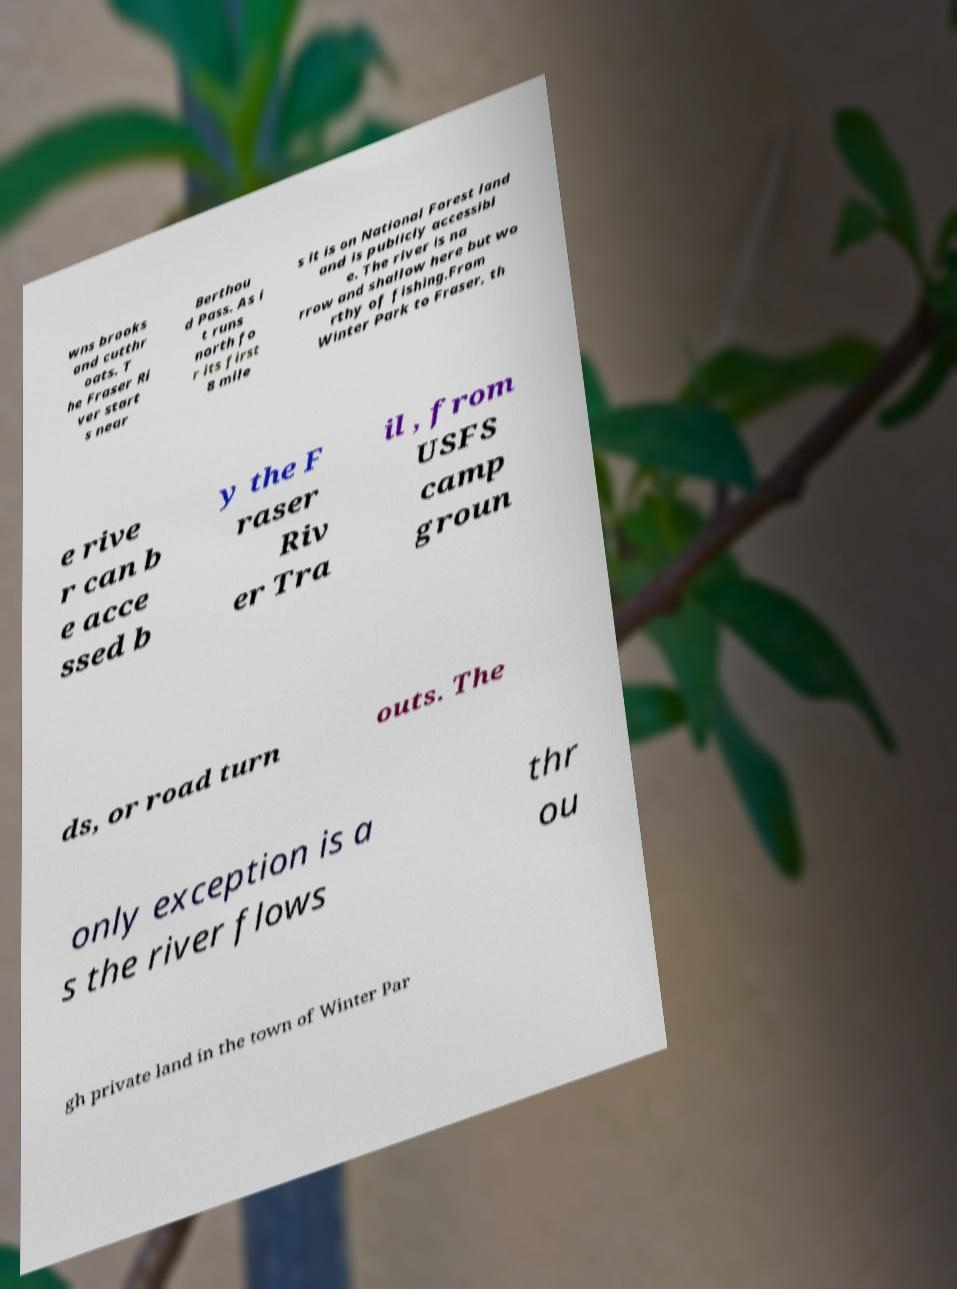I need the written content from this picture converted into text. Can you do that? wns brooks and cutthr oats. T he Fraser Ri ver start s near Berthou d Pass. As i t runs north fo r its first 8 mile s it is on National Forest land and is publicly accessibl e. The river is na rrow and shallow here but wo rthy of fishing.From Winter Park to Fraser, th e rive r can b e acce ssed b y the F raser Riv er Tra il , from USFS camp groun ds, or road turn outs. The only exception is a s the river flows thr ou gh private land in the town of Winter Par 